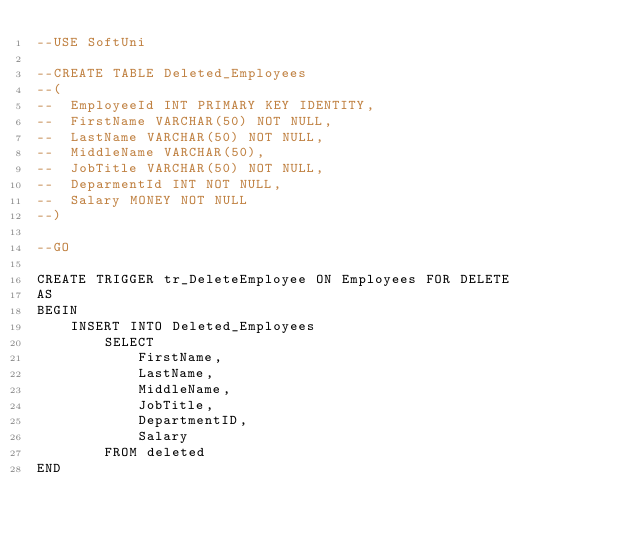Convert code to text. <code><loc_0><loc_0><loc_500><loc_500><_SQL_>--USE SoftUni

--CREATE TABLE Deleted_Employees
--(
--	EmployeeId INT PRIMARY KEY IDENTITY,
--	FirstName VARCHAR(50) NOT NULL,
--	LastName VARCHAR(50) NOT NULL,
--	MiddleName VARCHAR(50),
--	JobTitle VARCHAR(50) NOT NULL,
--	DeparmentId INT NOT NULL, 
--	Salary MONEY NOT NULL
--)

--GO

CREATE TRIGGER tr_DeleteEmployee ON Employees FOR DELETE
AS
BEGIN
	INSERT INTO Deleted_Employees
		SELECT 
			FirstName,
			LastName,
			MiddleName,
			JobTitle,
			DepartmentID,
			Salary
		FROM deleted
END</code> 